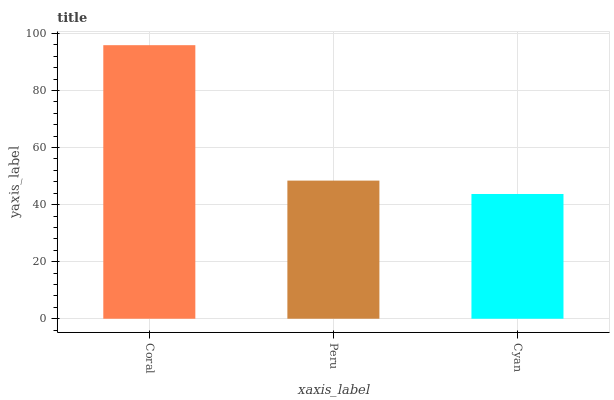Is Peru the minimum?
Answer yes or no. No. Is Peru the maximum?
Answer yes or no. No. Is Coral greater than Peru?
Answer yes or no. Yes. Is Peru less than Coral?
Answer yes or no. Yes. Is Peru greater than Coral?
Answer yes or no. No. Is Coral less than Peru?
Answer yes or no. No. Is Peru the high median?
Answer yes or no. Yes. Is Peru the low median?
Answer yes or no. Yes. Is Coral the high median?
Answer yes or no. No. Is Cyan the low median?
Answer yes or no. No. 